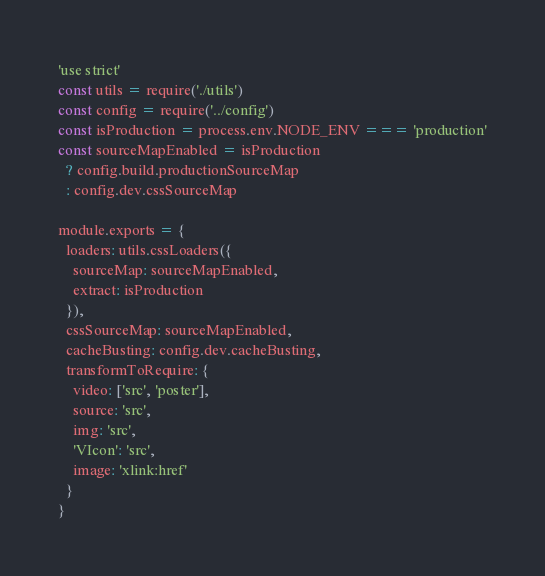<code> <loc_0><loc_0><loc_500><loc_500><_JavaScript_>'use strict'
const utils = require('./utils')
const config = require('../config')
const isProduction = process.env.NODE_ENV === 'production'
const sourceMapEnabled = isProduction
  ? config.build.productionSourceMap
  : config.dev.cssSourceMap

module.exports = {
  loaders: utils.cssLoaders({
    sourceMap: sourceMapEnabled,
    extract: isProduction
  }),
  cssSourceMap: sourceMapEnabled,
  cacheBusting: config.dev.cacheBusting,
  transformToRequire: {
    video: ['src', 'poster'],
    source: 'src',
    img: 'src',
    'VIcon': 'src',
    image: 'xlink:href'
  }
}
</code> 